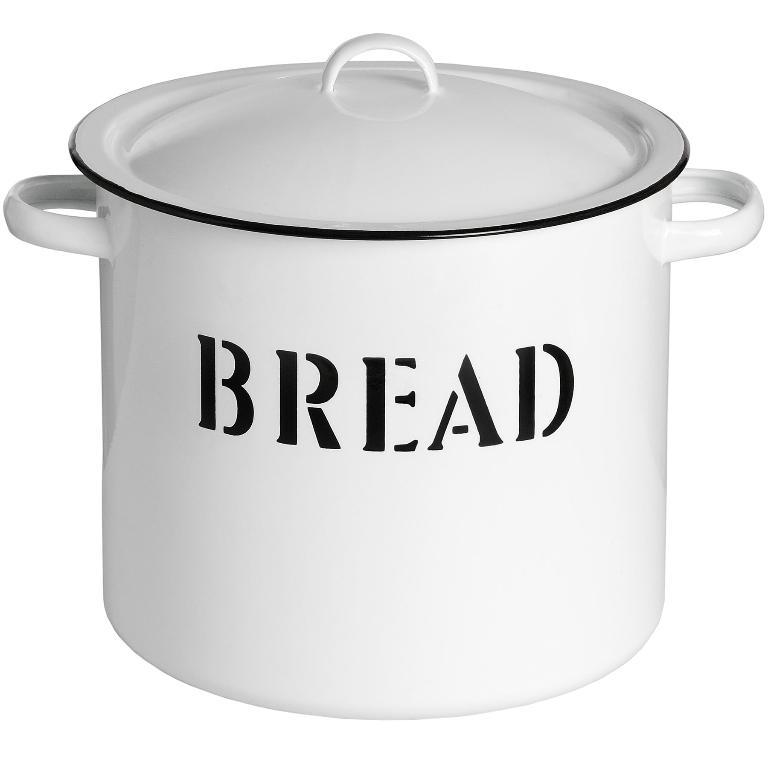What object can be seen in the image that is used for eating or cooking? There is an utensil in the image. What color is the background of the image? The background of the image is white. Can you see a tiger pulling a thread in the image? No, there is no tiger or thread present in the image. 